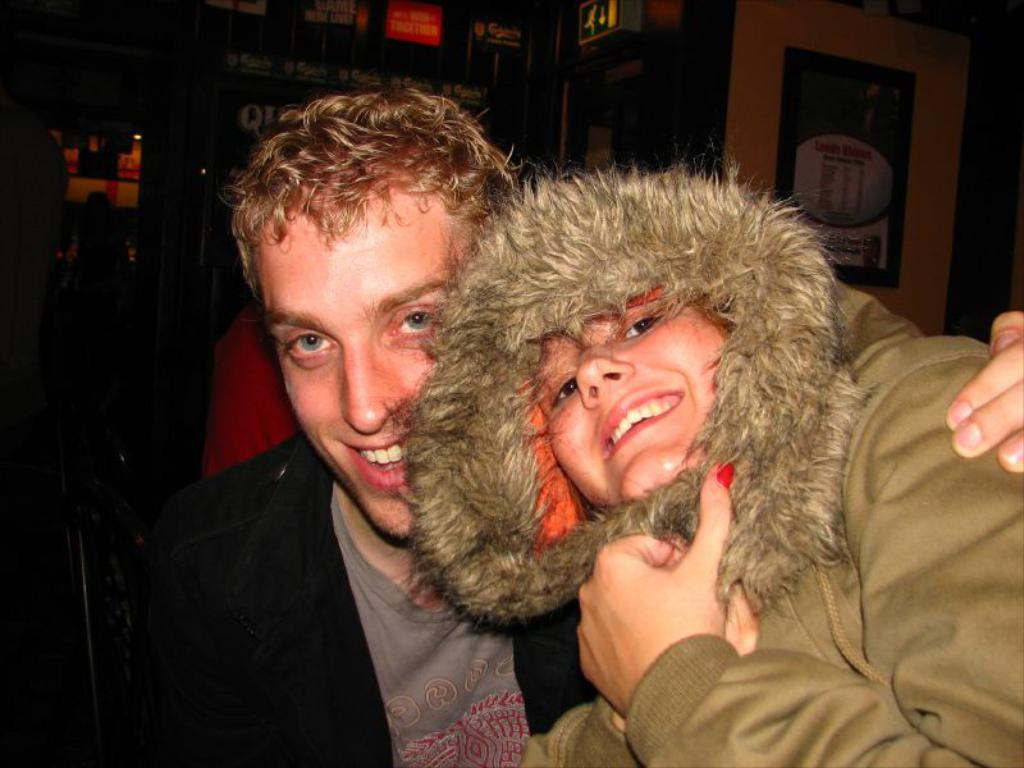Who is present in the image? There is a man and a woman in the image. What are the facial expressions of the people in the image? The man and the woman are both smiling. How many geese can be seen in the image? There are no geese present in the image. What type of hen is visible in the image? There is no hen present in the image. 